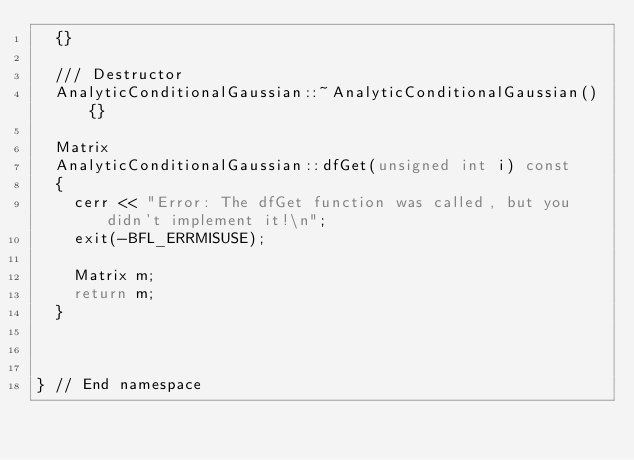<code> <loc_0><loc_0><loc_500><loc_500><_C++_>  {}

  /// Destructor
  AnalyticConditionalGaussian::~AnalyticConditionalGaussian(){}

  Matrix
  AnalyticConditionalGaussian::dfGet(unsigned int i) const
  {
    cerr << "Error: The dfGet function was called, but you didn't implement it!\n";
    exit(-BFL_ERRMISUSE);

    Matrix m;
    return m;
  }



} // End namespace
</code> 